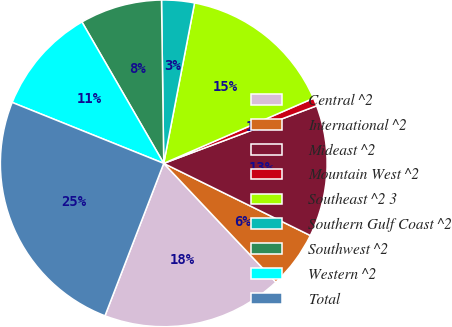<chart> <loc_0><loc_0><loc_500><loc_500><pie_chart><fcel>Central ^2<fcel>International ^2<fcel>Mideast ^2<fcel>Mountain West ^2<fcel>Southeast ^2 3<fcel>Southern Gulf Coast ^2<fcel>Southwest ^2<fcel>Western ^2<fcel>Total<nl><fcel>17.9%<fcel>5.68%<fcel>13.01%<fcel>0.8%<fcel>15.45%<fcel>3.24%<fcel>8.13%<fcel>10.57%<fcel>25.23%<nl></chart> 